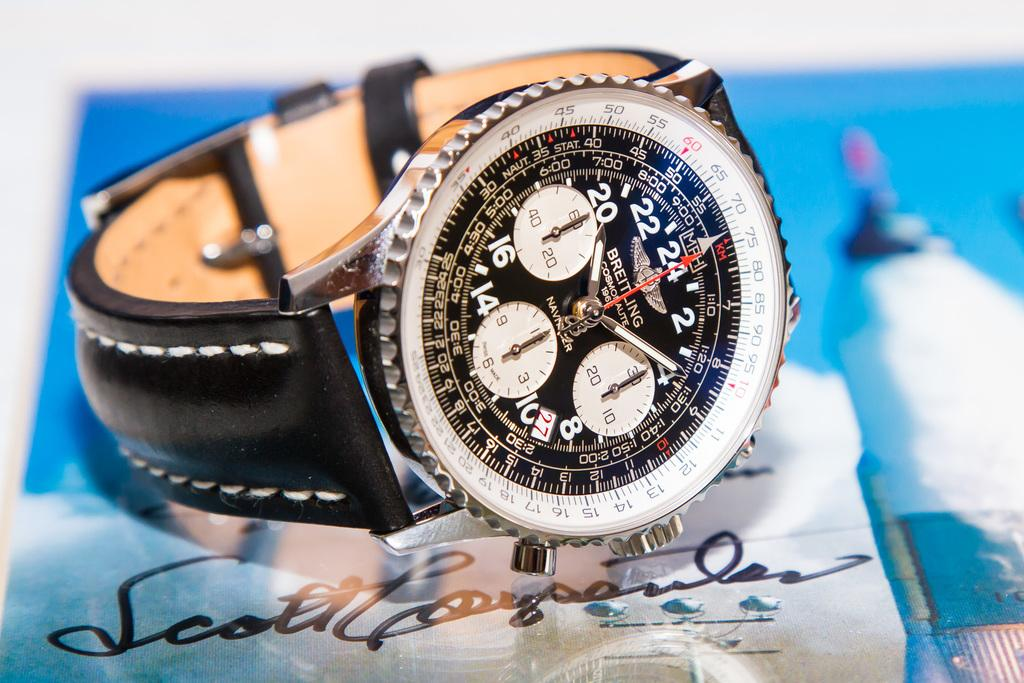<image>
Present a compact description of the photo's key features. An ad for Breitling watches with a leather banded watch on top of an autograph. 